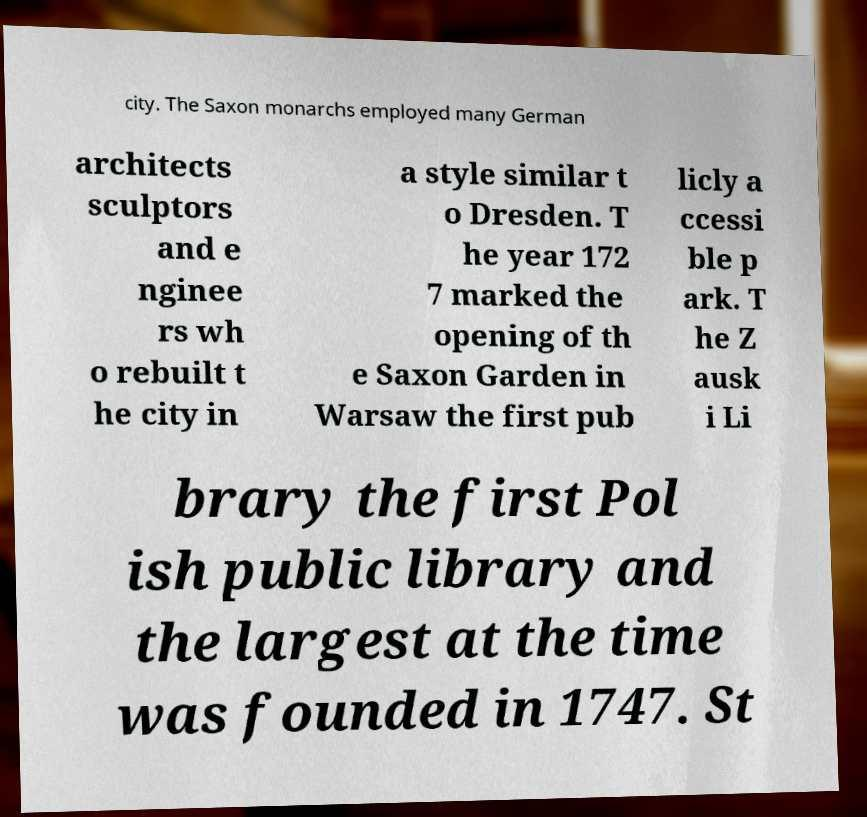Could you assist in decoding the text presented in this image and type it out clearly? city. The Saxon monarchs employed many German architects sculptors and e nginee rs wh o rebuilt t he city in a style similar t o Dresden. T he year 172 7 marked the opening of th e Saxon Garden in Warsaw the first pub licly a ccessi ble p ark. T he Z ausk i Li brary the first Pol ish public library and the largest at the time was founded in 1747. St 